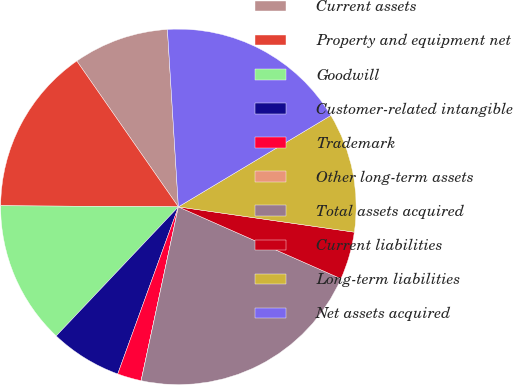Convert chart to OTSL. <chart><loc_0><loc_0><loc_500><loc_500><pie_chart><fcel>Current assets<fcel>Property and equipment net<fcel>Goodwill<fcel>Customer-related intangible<fcel>Trademark<fcel>Other long-term assets<fcel>Total assets acquired<fcel>Current liabilities<fcel>Long-term liabilities<fcel>Net assets acquired<nl><fcel>8.7%<fcel>15.22%<fcel>13.04%<fcel>6.52%<fcel>2.18%<fcel>0.0%<fcel>21.74%<fcel>4.35%<fcel>10.87%<fcel>17.39%<nl></chart> 